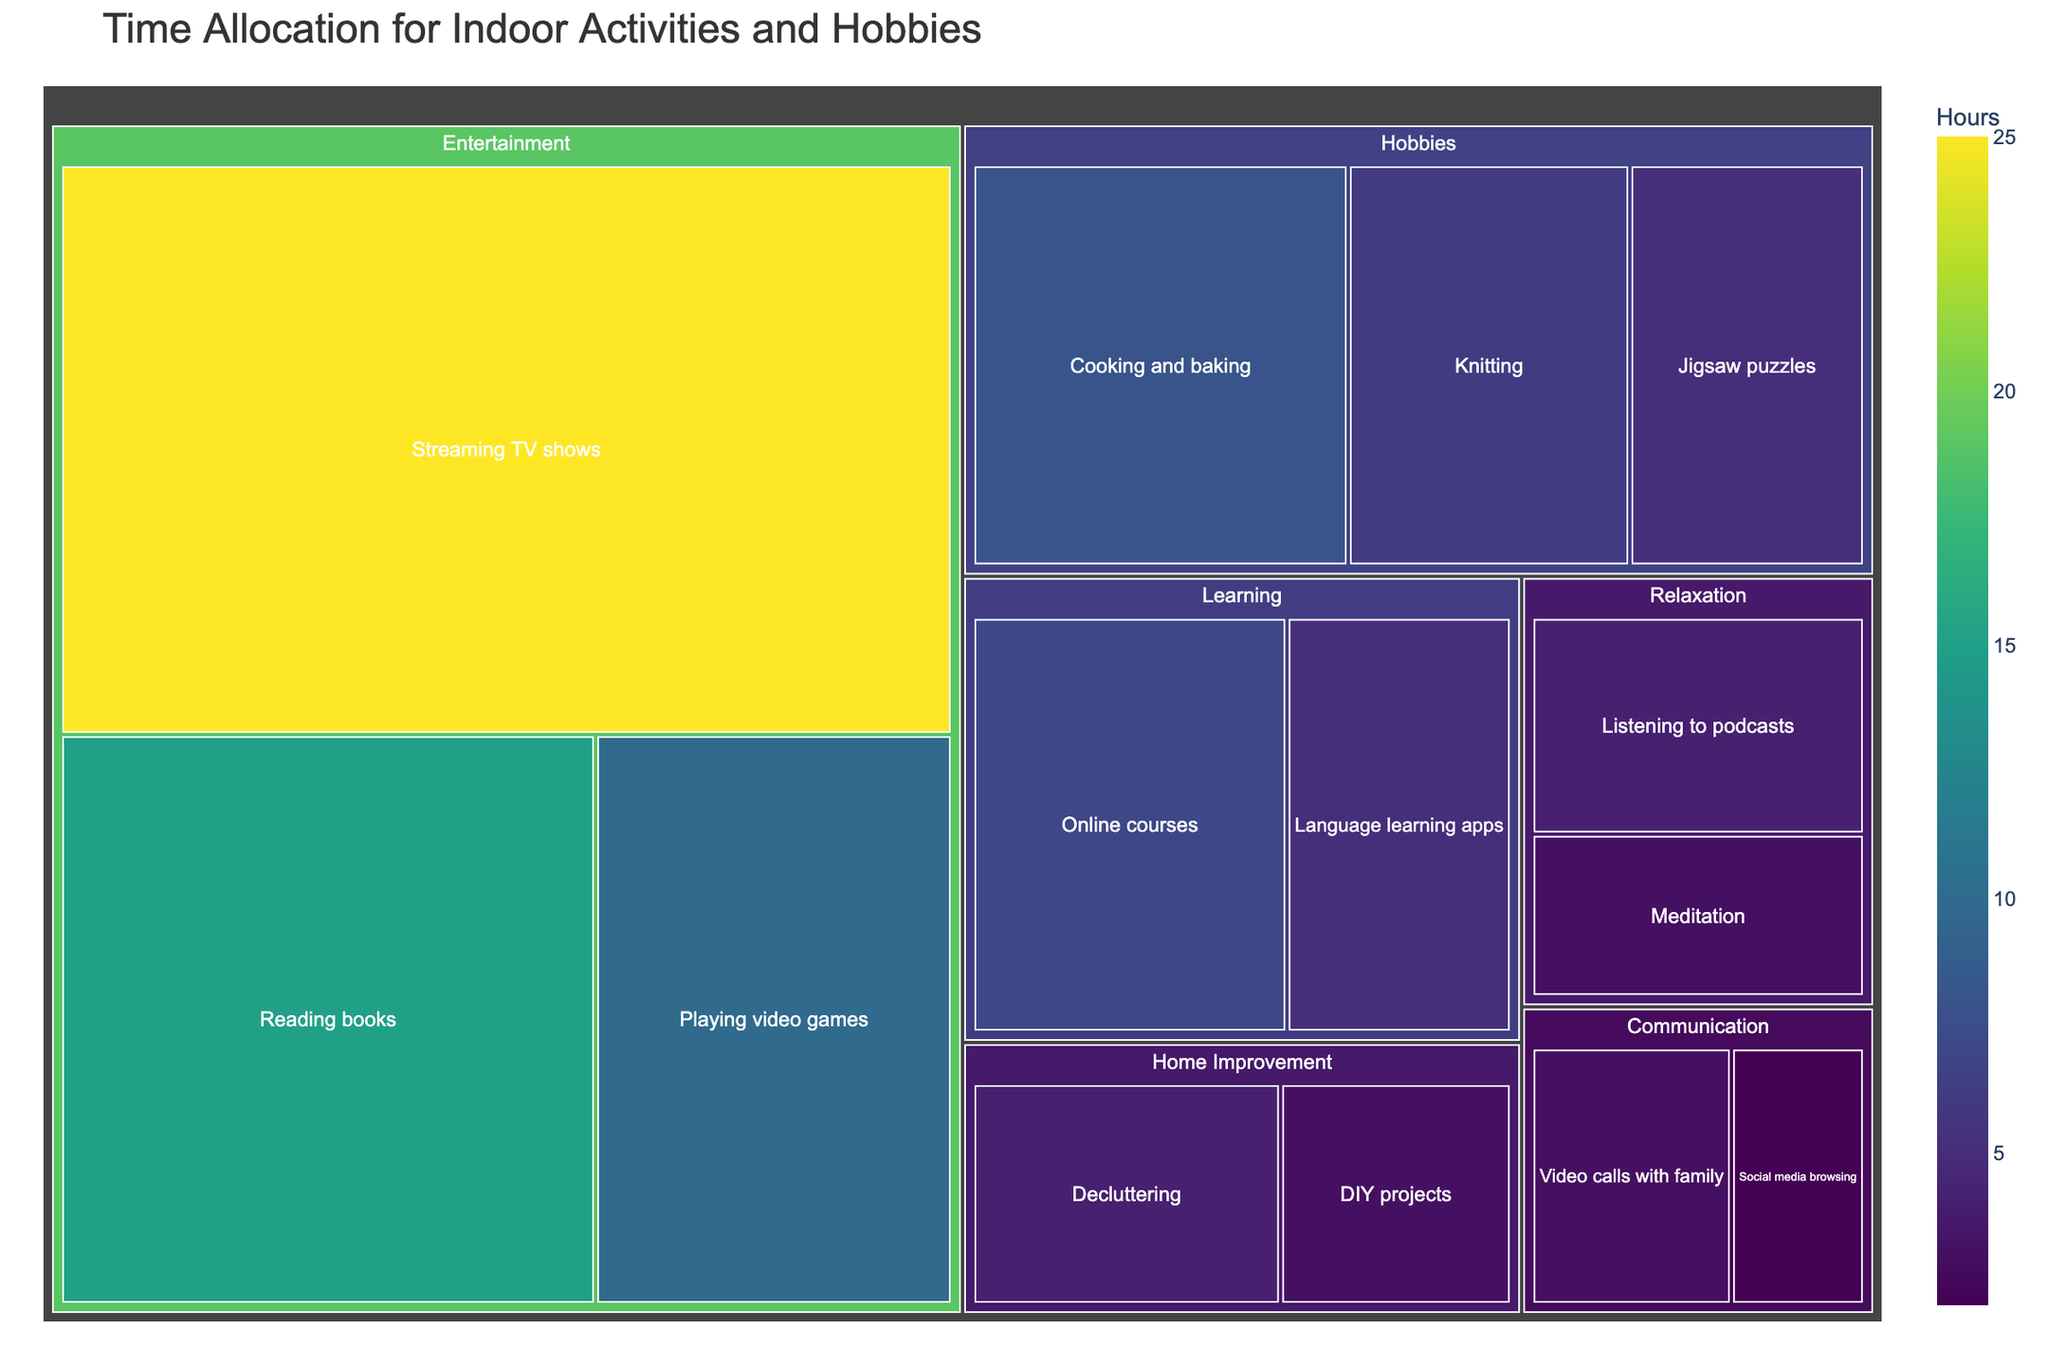what is the total time allocated to Entertainment activities? The Treemap categorizes "Streaming TV shows", "Reading books", and "Playing video games" under Entertainment. The total time is the sum of these activities: 25 + 15 + 10 = 50 hours
Answer: 50 hours Which activity has the most hours allocated? By looking at the largest block in the Treemap, "Streaming TV shows" has the most hours allocated with a value of 25 hours.
Answer: Streaming TV shows Which category contains the least amount of total time? The category with the smallest total hours in the Treemap block is "Communication," which is 3 hours for "Video calls with family" and 2 hours for "Social media browsing" summing up to 5 hours.
Answer: Communication What is the ratio of time spent on "Reading books" to "Cooking and baking"? According to the Treemap, time spent on "Reading books" is 15 hours and on "Cooking and baking" is 8 hours. The ratio is 15/8.
Answer: 15:8 Which category has more time allocated: Hobbies or Home Improvement? Adding the hours in both categories: Hobbies (8 + 6 + 5 = 19 hours) and Home Improvement (4 + 3 = 7 hours). Hobbies have more time allocated.
Answer: Hobbies How much more time is spent on "Listening to podcasts" compared to "Meditation"? "Listening to podcasts" has 4 hours and "Meditation" has 3 hours. The difference is 4 - 3 = 1 hour.
Answer: 1 hour What is the average time spent on activities under the Learning category? "Online courses" and "Language learning apps" are under Learning, allocating 7 hours and 5 hours respectively. The average is (7 + 5) / 2 = 6 hours.
Answer: 6 hours Is more time spent communicating through video calls or browsing social media? Video calls have 3 hours and social media browsing has 2 hours as per the Treemap. So, more time is spent on video calls.
Answer: Video calls What proportion of the total hours is allocated to "Cooking and baking"? Total hours summed from all activities is 90 hours. "Cooking and baking" has 8 hours. Thus, the proportion is 8 / 90, which simplifies to approximately 0.089 or 8.9%.
Answer: 8.9% What is the combined total time of “Knitting” and “Jigsaw puzzles”? According to the Treemap, "Knitting" takes 6 hours and "Jigsaw puzzles" takes 5 hours. Adding these, 6 + 5 = 11 hours.
Answer: 11 hours 